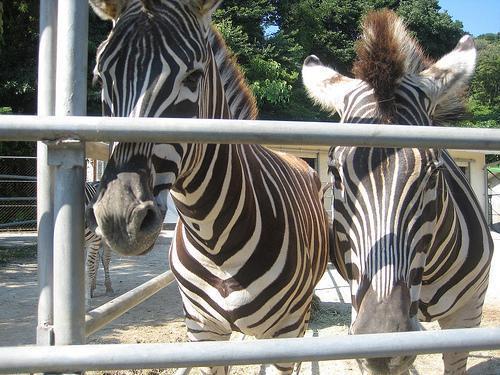How many zebras are in the picture?
Give a very brief answer. 3. 